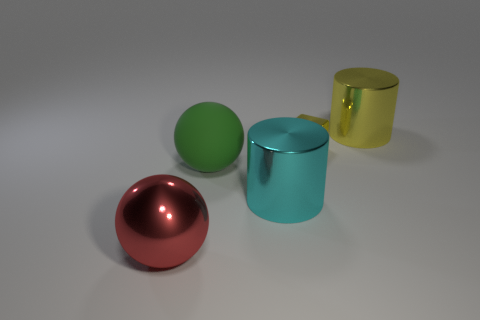There is a large thing that is both to the right of the green thing and in front of the large yellow cylinder; what is its shape? The object in question is a cylinder with a turquoise hue. It's positioned to the right of the green sphere on the side and partially in front of the yellow cylinder when viewed from the current perspective. 